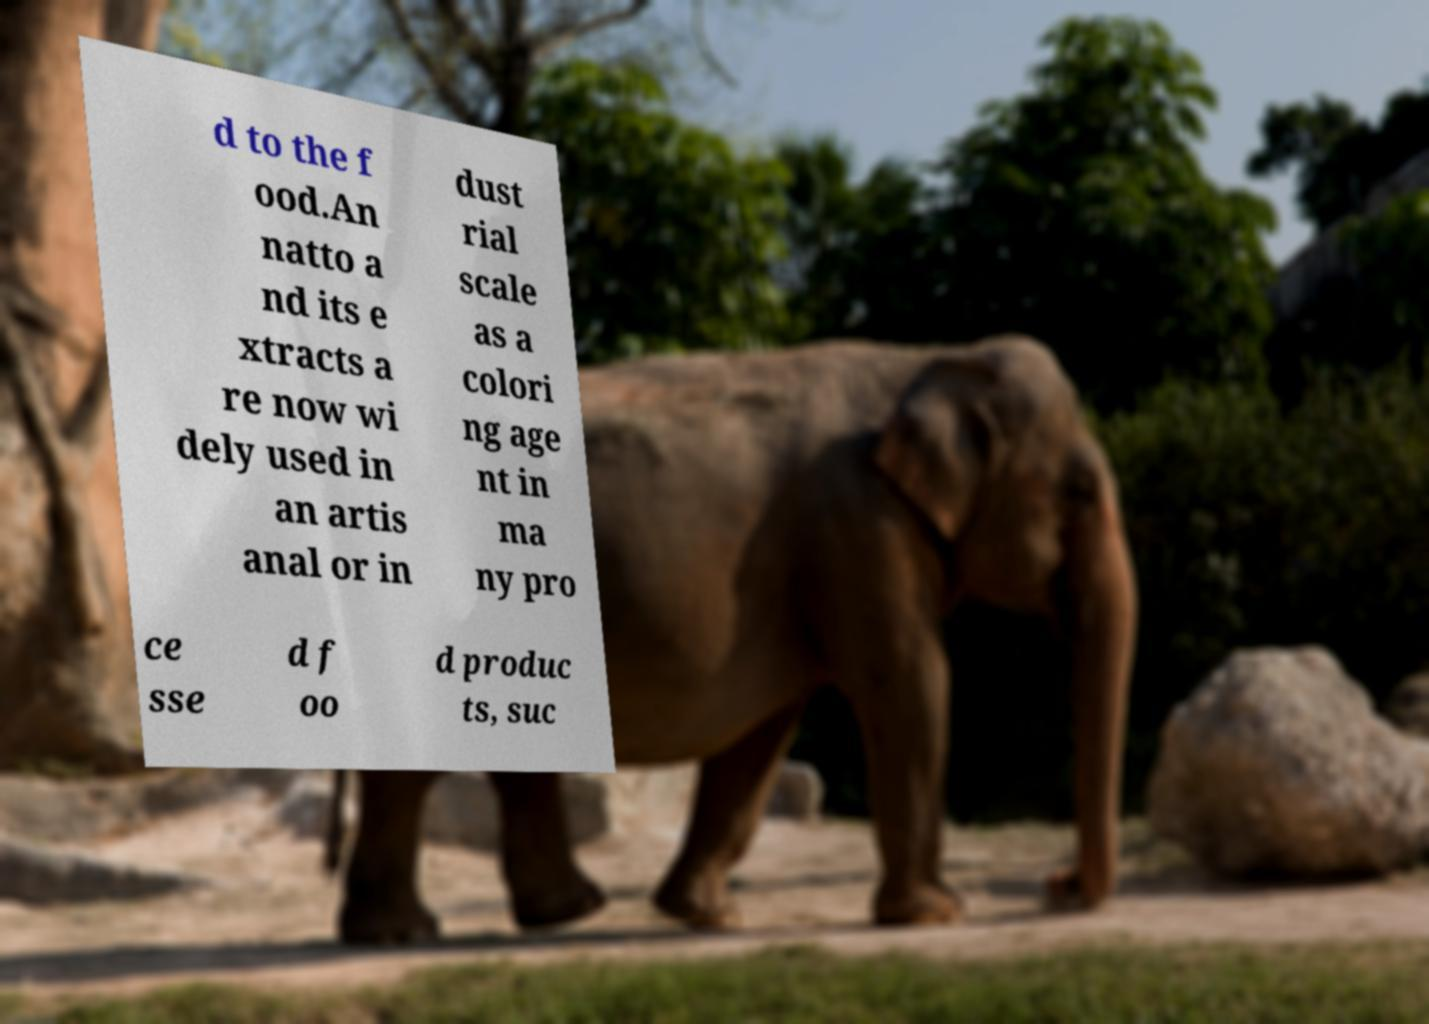Please read and relay the text visible in this image. What does it say? d to the f ood.An natto a nd its e xtracts a re now wi dely used in an artis anal or in dust rial scale as a colori ng age nt in ma ny pro ce sse d f oo d produc ts, suc 